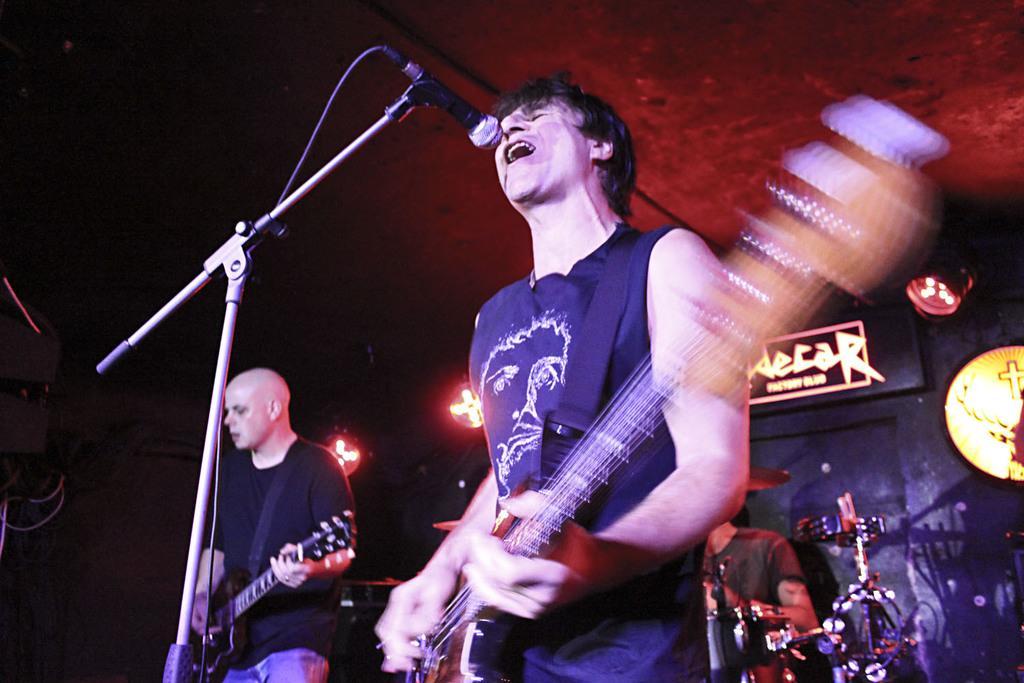Could you give a brief overview of what you see in this image? The picture is taken on the stage on which one person is holding a guitar on the left corner and one person in the middle singing a song in the microphone in front of him and behind him one person is sitting and playing drums and behind them there is one black wall and a lighting board is present on it. 